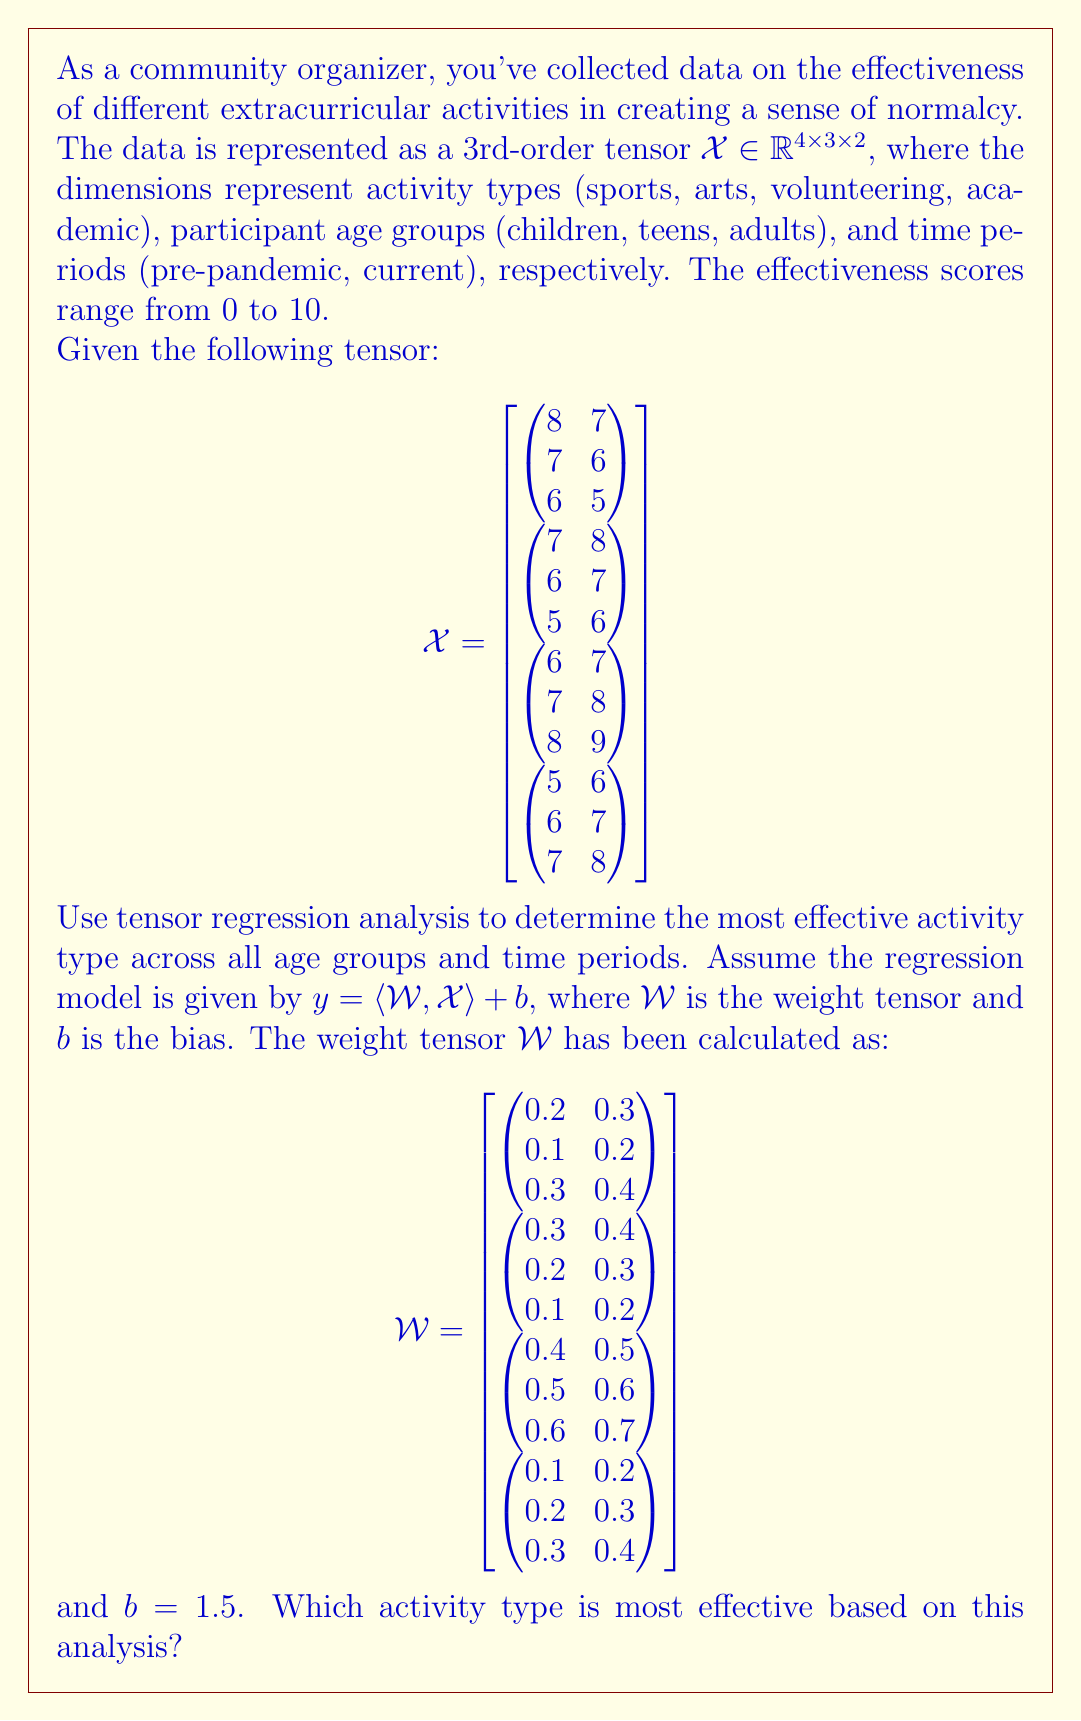Solve this math problem. To determine the most effective activity type, we need to calculate the regression output for each activity type and compare the results. We'll use the formula $y = \langle \mathcal{W}, \mathcal{X} \rangle + b$, where $\langle \mathcal{W}, \mathcal{X} \rangle$ denotes the tensor contraction (element-wise multiplication and sum) of $\mathcal{W}$ and $\mathcal{X}$.

Step 1: Calculate the tensor contraction for each activity type.

1. Sports (first slice of $\mathcal{X}$ and $\mathcal{W}$):
   $$(8 \cdot 0.2 + 7 \cdot 0.3) + (7 \cdot 0.1 + 6 \cdot 0.2) + (6 \cdot 0.3 + 5 \cdot 0.4) = 7.9$$

2. Arts (second slice):
   $$(7 \cdot 0.3 + 8 \cdot 0.4) + (6 \cdot 0.2 + 7 \cdot 0.3) + (5 \cdot 0.1 + 6 \cdot 0.2) = 8.3$$

3. Volunteering (third slice):
   $$(6 \cdot 0.4 + 7 \cdot 0.5) + (7 \cdot 0.5 + 8 \cdot 0.6) + (8 \cdot 0.6 + 9 \cdot 0.7) = 15.9$$

4. Academic (fourth slice):
   $$(5 \cdot 0.1 + 6 \cdot 0.2) + (6 \cdot 0.2 + 7 \cdot 0.3) + (7 \cdot 0.3 + 8 \cdot 0.4) = 8.7$$

Step 2: Add the bias term $b = 1.5$ to each result.

1. Sports: $7.9 + 1.5 = 9.4$
2. Arts: $8.3 + 1.5 = 9.8$
3. Volunteering: $15.9 + 1.5 = 17.4$
4. Academic: $8.7 + 1.5 = 10.2$

Step 3: Compare the results to determine the most effective activity type.

The highest value corresponds to the most effective activity type. In this case, volunteering has the highest value of 17.4.
Answer: Volunteering 